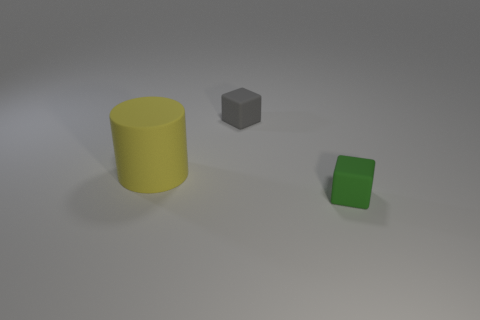Add 3 gray blocks. How many objects exist? 6 Subtract 0 yellow balls. How many objects are left? 3 Subtract all cylinders. How many objects are left? 2 Subtract 2 blocks. How many blocks are left? 0 Subtract all blue blocks. Subtract all blue spheres. How many blocks are left? 2 Subtract all red cubes. How many red cylinders are left? 0 Subtract all gray rubber blocks. Subtract all purple metal cylinders. How many objects are left? 2 Add 2 green cubes. How many green cubes are left? 3 Add 2 yellow metal spheres. How many yellow metal spheres exist? 2 Subtract all green cubes. How many cubes are left? 1 